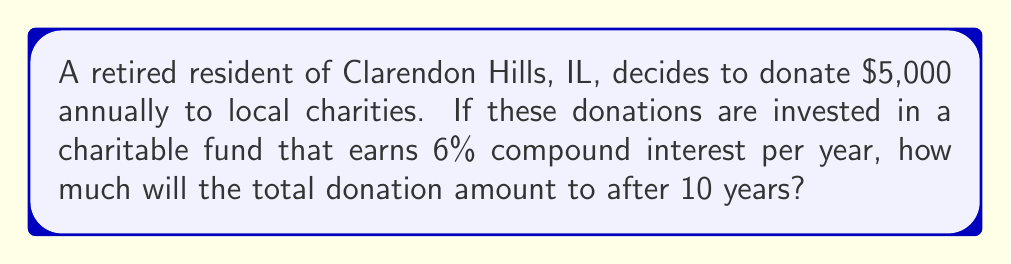Show me your answer to this math problem. To solve this problem, we'll use the compound interest formula for regular contributions:

$$A = P \cdot \frac{(1 + r)^n - 1}{r}$$

Where:
$A$ = Final amount
$P$ = Annual contribution (donation)
$r$ = Annual interest rate (as a decimal)
$n$ = Number of years

Given:
$P = \$5,000$
$r = 0.06$ (6% as a decimal)
$n = 10$ years

Let's substitute these values into the formula:

$$A = 5000 \cdot \frac{(1 + 0.06)^{10} - 1}{0.06}$$

Now, let's solve step-by-step:

1) First, calculate $(1 + 0.06)^{10}$:
   $$(1.06)^{10} = 1.7908$$

2) Subtract 1 from this result:
   $$1.7908 - 1 = 0.7908$$

3) Divide by 0.06:
   $$\frac{0.7908}{0.06} = 13.18$$

4) Multiply by the annual contribution:
   $$5000 \cdot 13.18 = 65,900$$

Therefore, the total donation amount after 10 years will be $65,900.
Answer: $65,900 